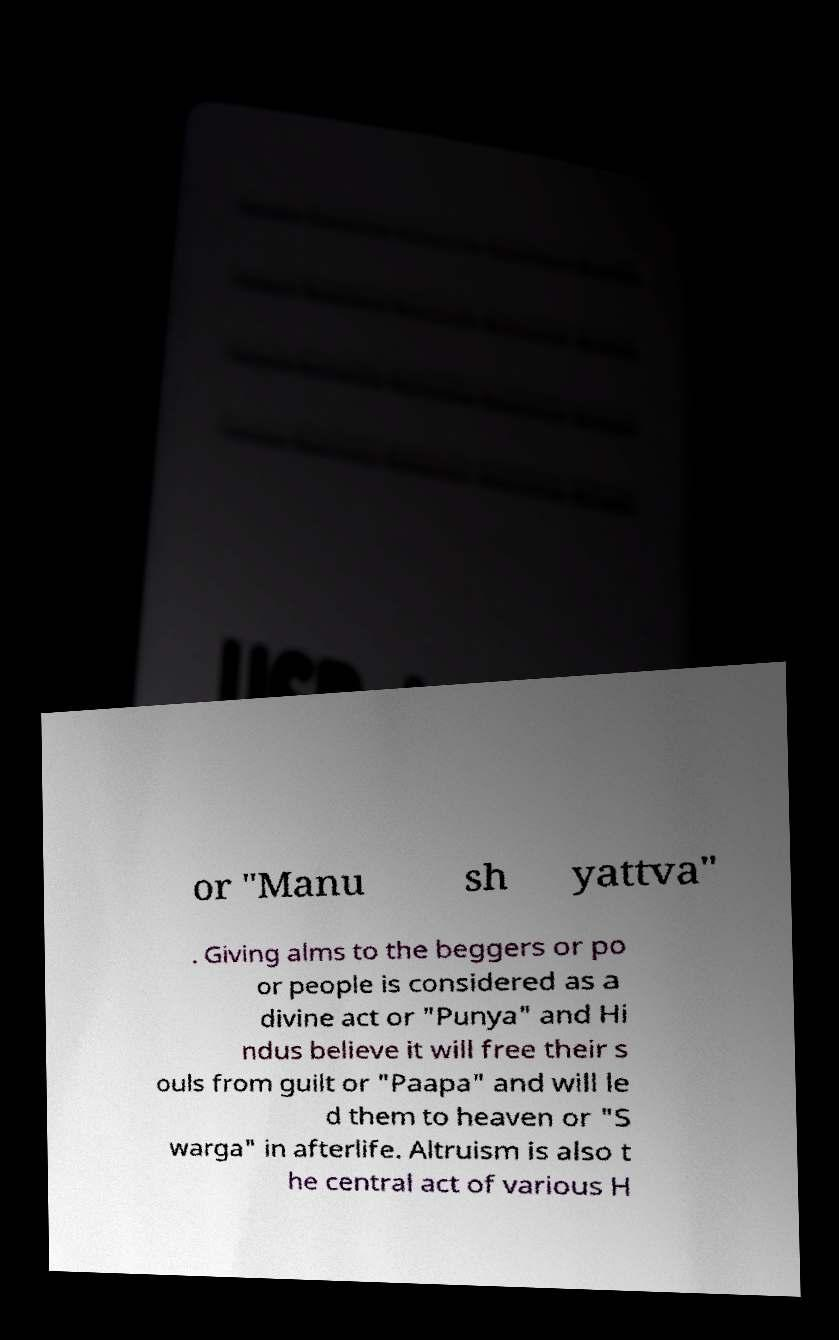Can you accurately transcribe the text from the provided image for me? or "Manu sh yattva" . Giving alms to the beggers or po or people is considered as a divine act or "Punya" and Hi ndus believe it will free their s ouls from guilt or "Paapa" and will le d them to heaven or "S warga" in afterlife. Altruism is also t he central act of various H 